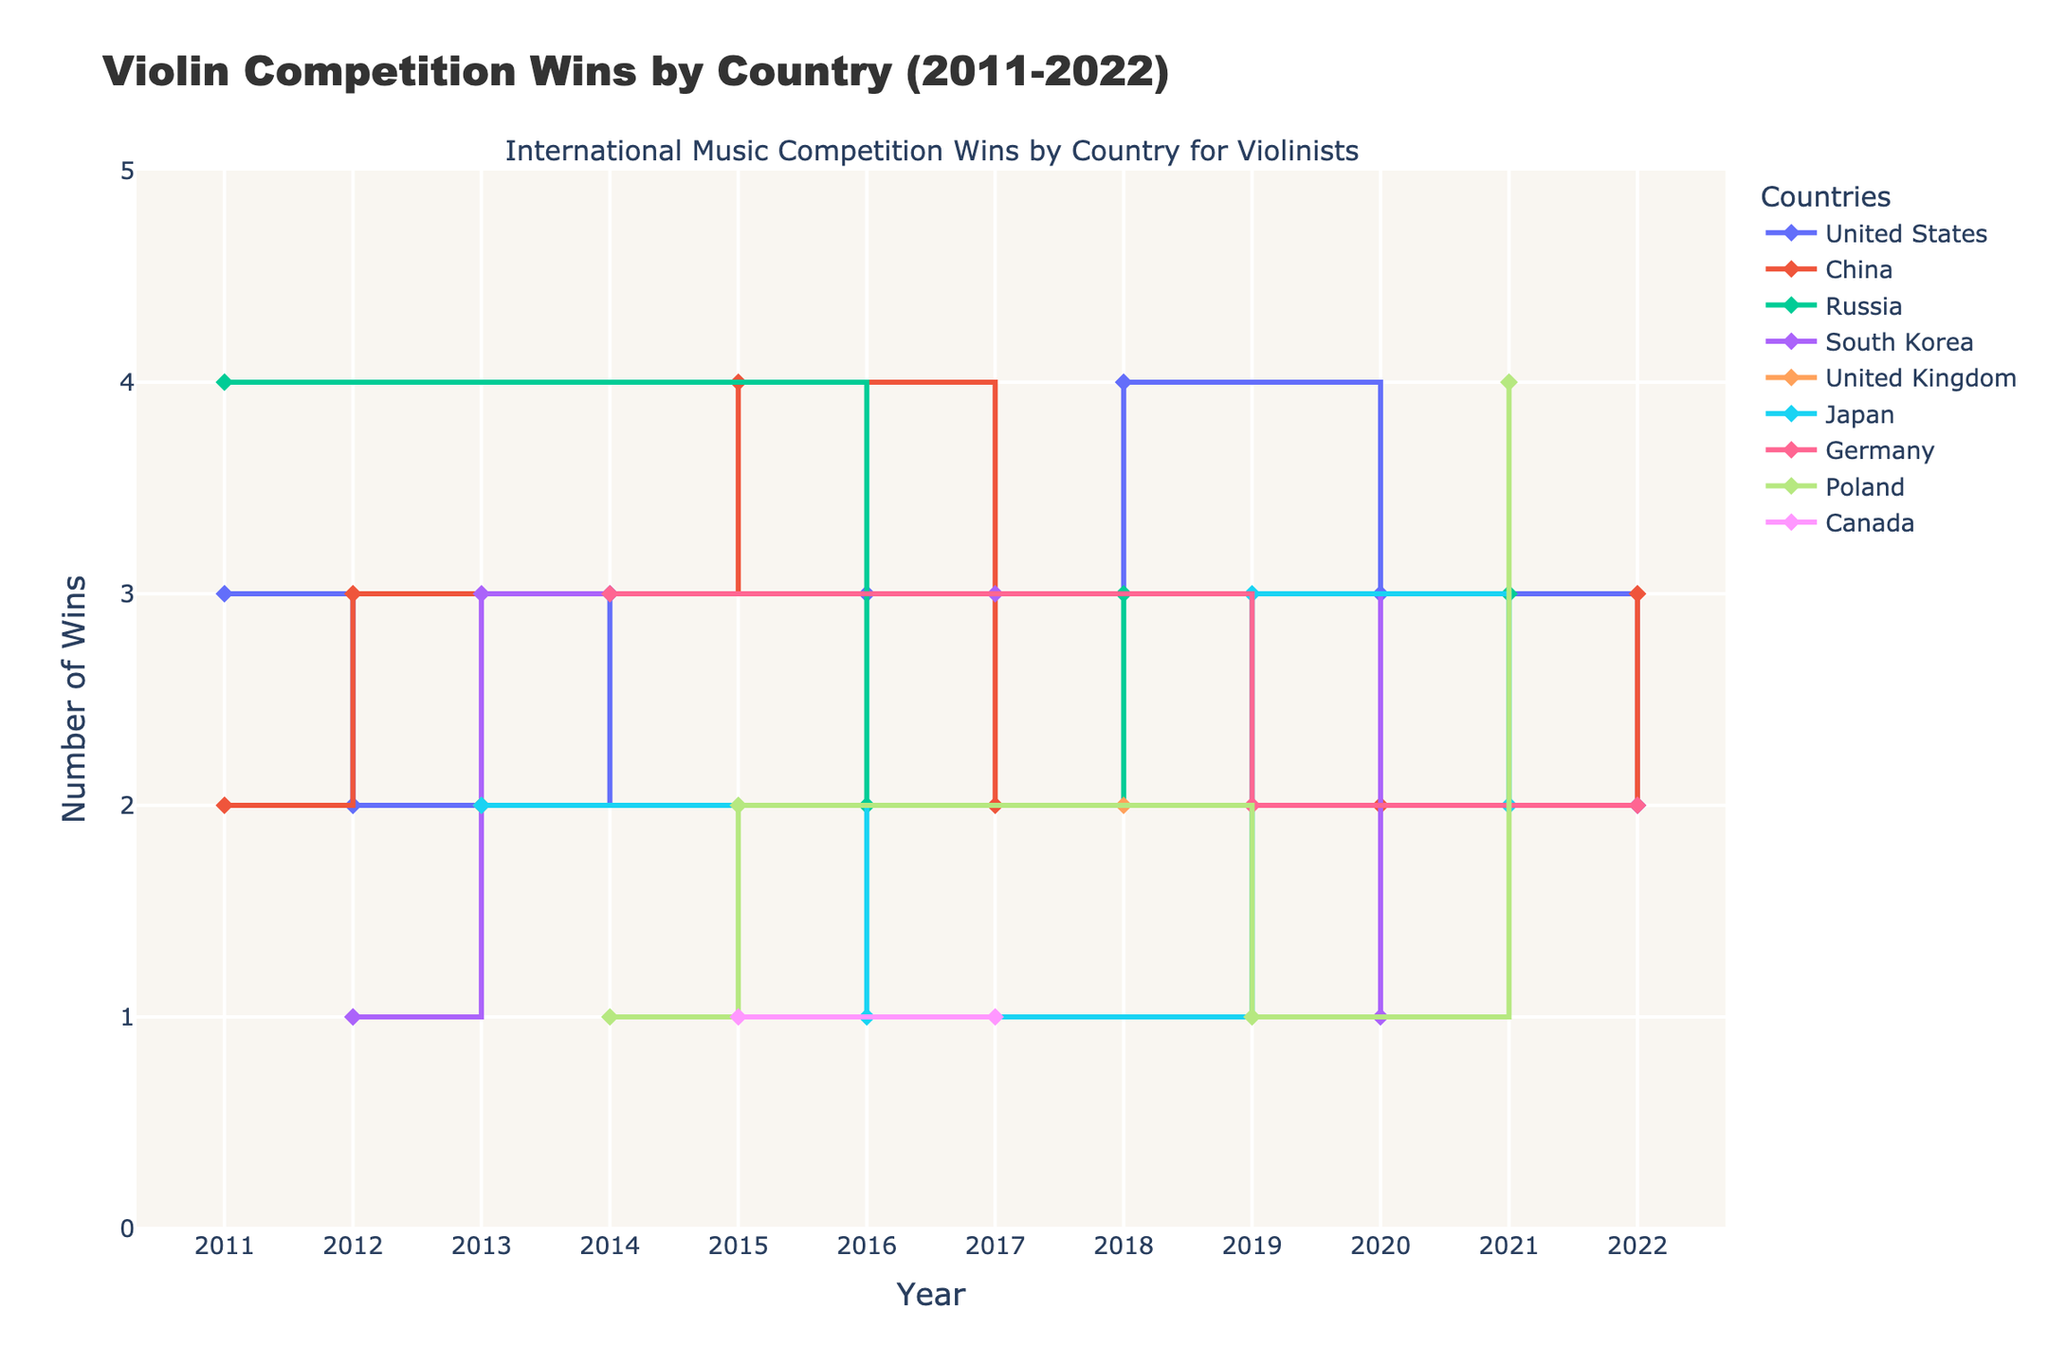What is the title of the plot? The title is usually displayed prominently at the top of the plot. Reading the top section, we see the title is "Violin Competition Wins by Country (2011-2022)."
Answer: Violin Competition Wins by Country (2011-2022) What is the range of years displayed on the x-axis? To identify the range, examine the x-axis at the bottom of the plot where years are marked. The years range from 2011 to 2022.
Answer: 2011-2022 Which country had the highest number of wins in 2018? To find this, locate the year 2018 on the x-axis and look at the corresponding points on the lines for each country. The United States had 4 wins.
Answer: United States Which country has the most number of data points (years recorded)? Count the markers along the line of each country. The United States has the most data points, indicating recorded wins for multiple years.
Answer: United States What is the total number of wins for China over the entire span? Sum the wins for China by looking at the height of the stairs corresponding to China for each year. The wins are: 2 (2011) + 3 (2012) + 4 (2015) + 2 (2017) + 2 (2020) + 3 (2022). The total is 16.
Answer: 16 Which country had the most consistent wins over the years? Consistent wins would appear as a stair plot with minimal fluctuations. The United States maintains a relatively stable number of wins each year.
Answer: United States What is the difference in the number of wins between South Korea and Japan in 2013? Check the points for both countries for the year 2013. South Korea has 3 wins, and Japan has 2 wins. The difference is 3 - 2 = 1.
Answer: 1 In which year did Russia achieve the highest number of wins? Follow the points along the Russia line and identify the year with the highest value. In 2011, Russia had 4 wins.
Answer: 2011 How many countries recorded wins in 2014? Look at the number of distinct countries that have markers at the year 2014. There are 3 countries: Germany, Poland, and the United States.
Answer: 3 Which country saw the largest single-year increase in wins, and in which year did it occur? Identify the steepest upward steps in any country's stair plot. China saw an increase from 2 wins in 2014 to 4 wins in 2015, an increase of 2 wins.
Answer: China, 2015 